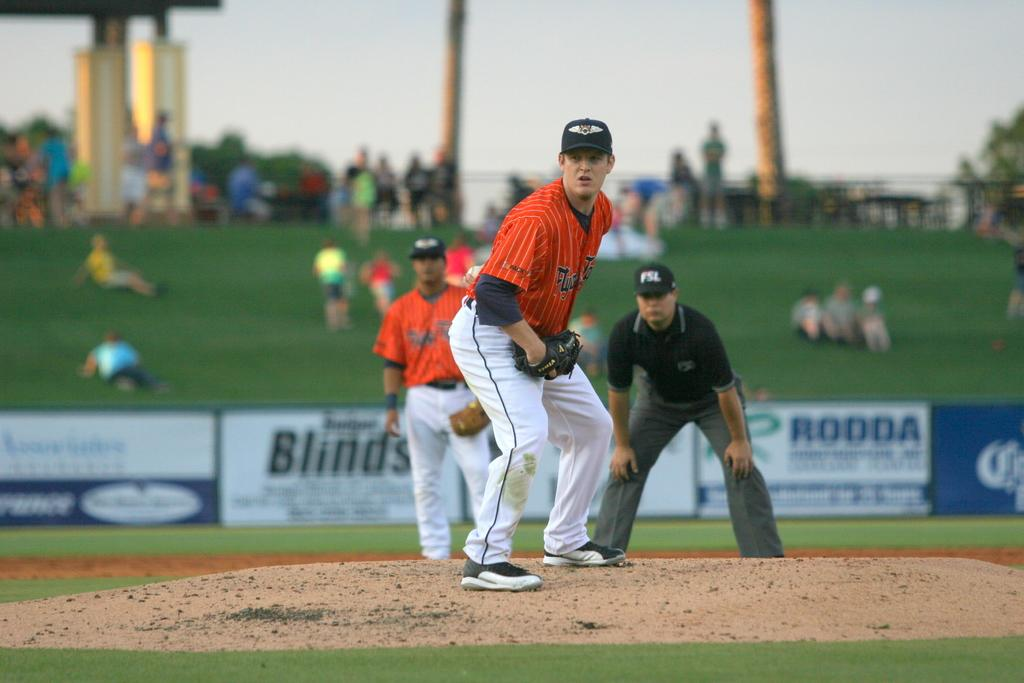<image>
Describe the image concisely. some baseball players, one has FSL on his cap and an ad in back says RODDA. 